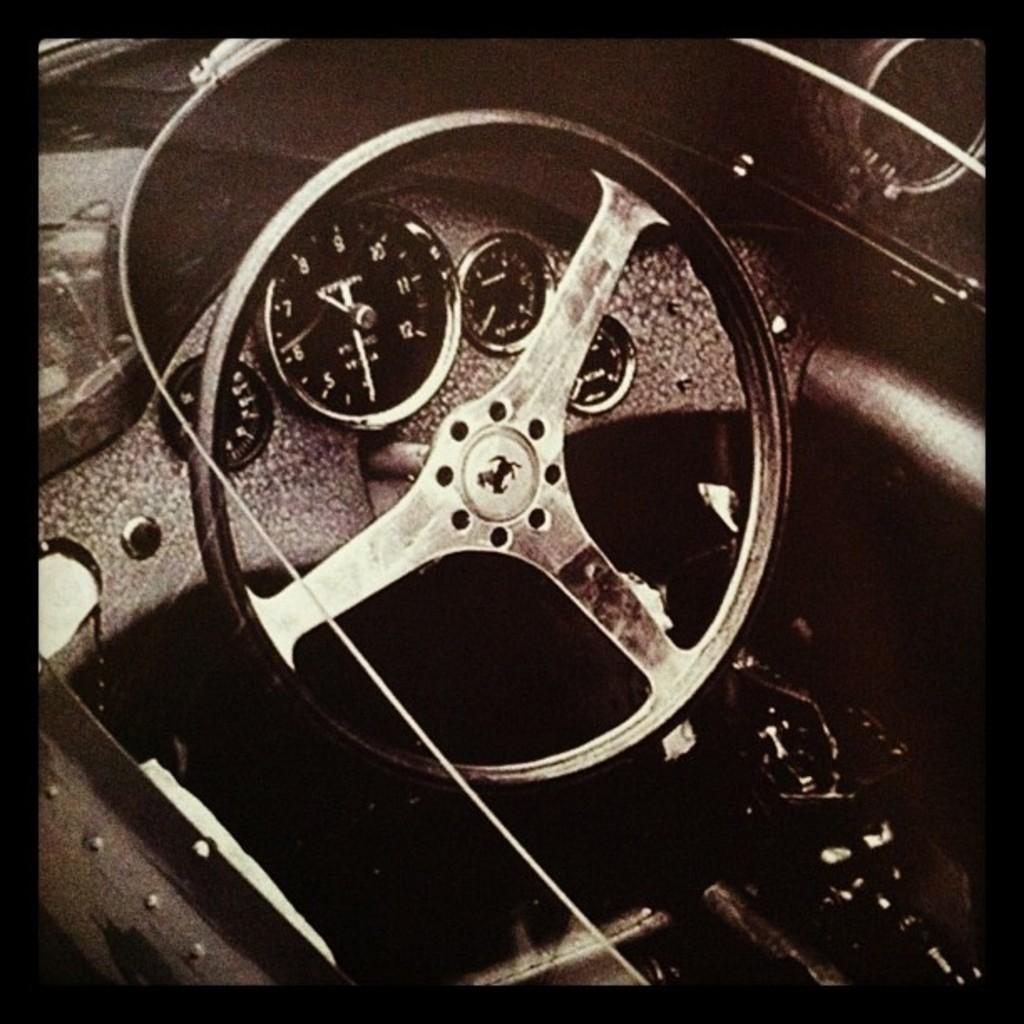What is the color scheme of the image? The image is black and white and edited. What is the setting of the image? The image shows an inside view of a vehicle. What is a prominent feature visible in the image? The steering wheel is visible in the image. What else can be seen in the image besides the steering wheel? There are other parts of the vehicle visible in the image. Is there a calculator visible on the dashboard in the image? No, there is no calculator visible on the dashboard in the image. Is there a sweater hanging from the rearview mirror in the image? No, there is no sweater hanging from the rearview mirror in the image. 